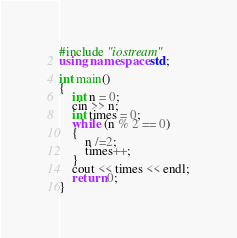<code> <loc_0><loc_0><loc_500><loc_500><_C++_>#include "iostream"
using namespace std;

int main()
{
	int n = 0;
	cin >> n;
	int times = 0;
	while (n % 2 == 0)
	{
		n /=2;
		times++;
	}
	cout << times << endl;
	return 0;
}

</code> 